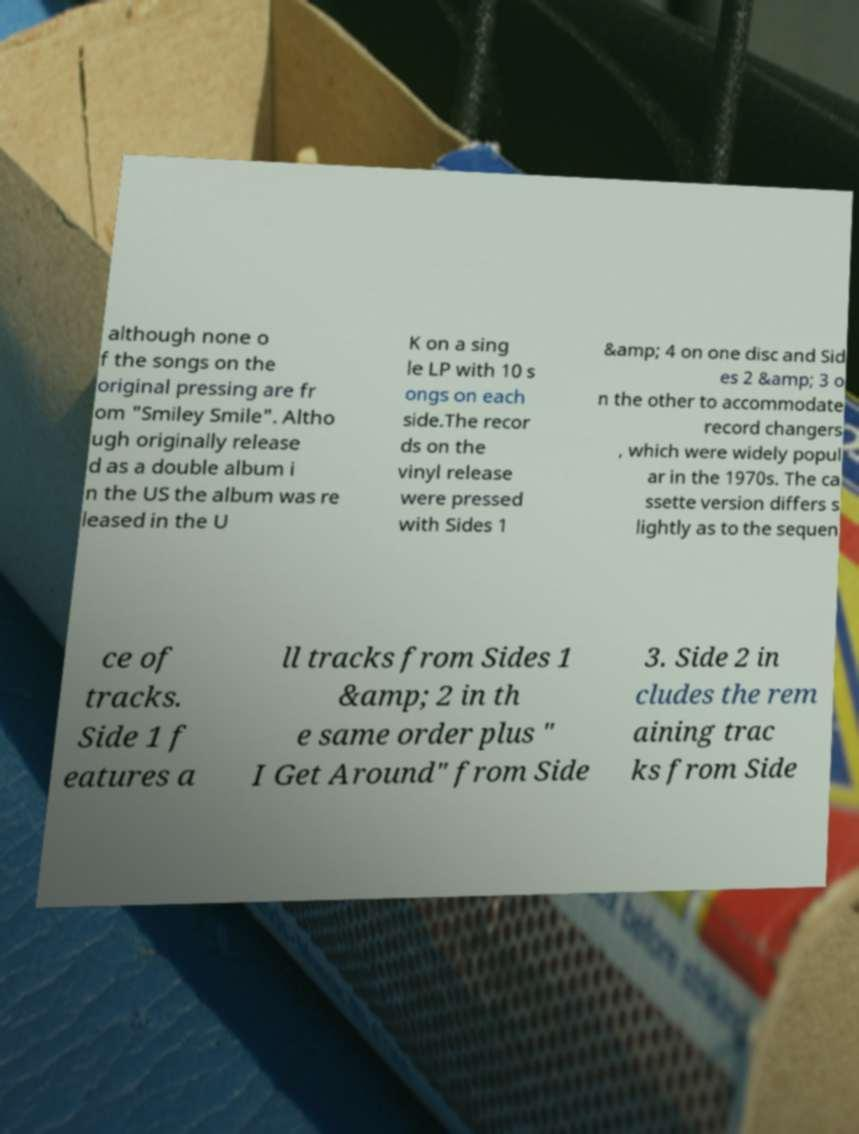Could you extract and type out the text from this image? although none o f the songs on the original pressing are fr om "Smiley Smile". Altho ugh originally release d as a double album i n the US the album was re leased in the U K on a sing le LP with 10 s ongs on each side.The recor ds on the vinyl release were pressed with Sides 1 &amp; 4 on one disc and Sid es 2 &amp; 3 o n the other to accommodate record changers , which were widely popul ar in the 1970s. The ca ssette version differs s lightly as to the sequen ce of tracks. Side 1 f eatures a ll tracks from Sides 1 &amp; 2 in th e same order plus " I Get Around" from Side 3. Side 2 in cludes the rem aining trac ks from Side 